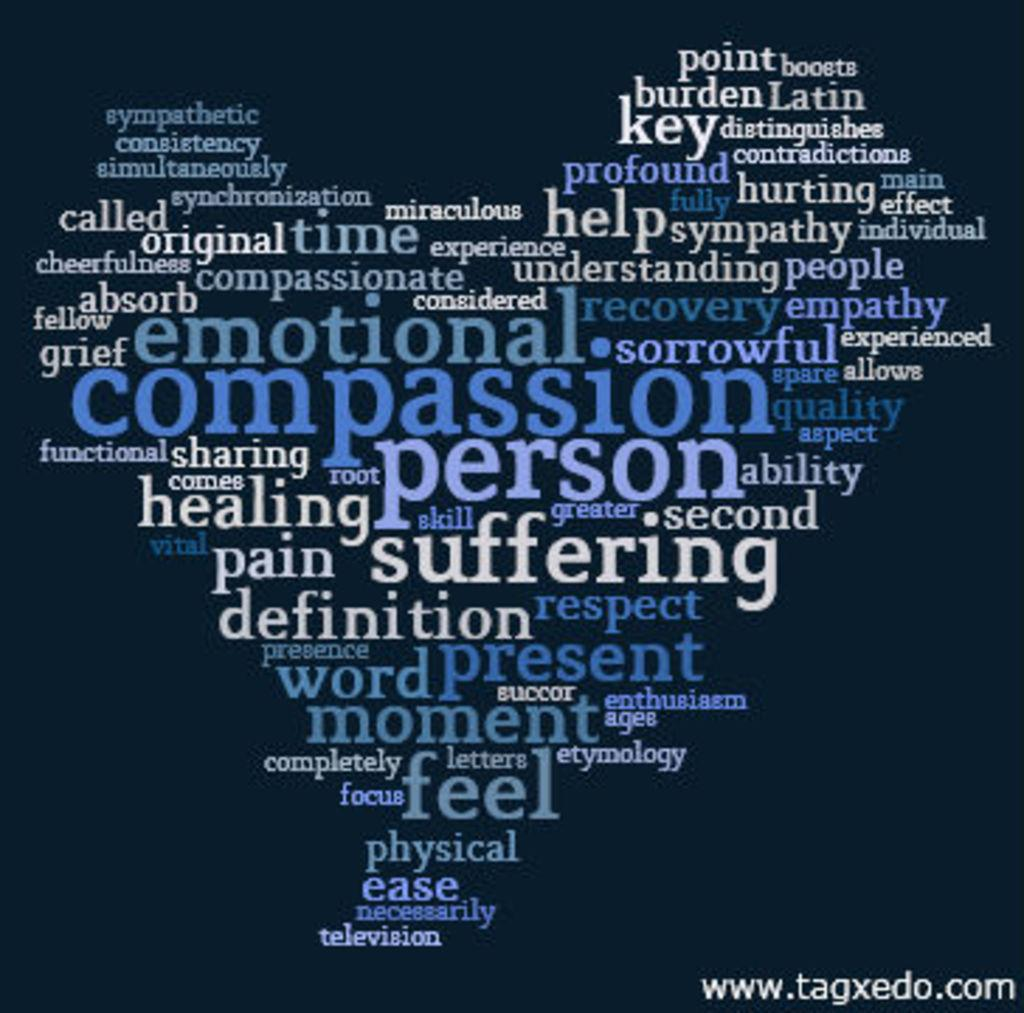Provide a one-sentence caption for the provided image. A word cloud of various emotions and and objects with compassion in the center. 